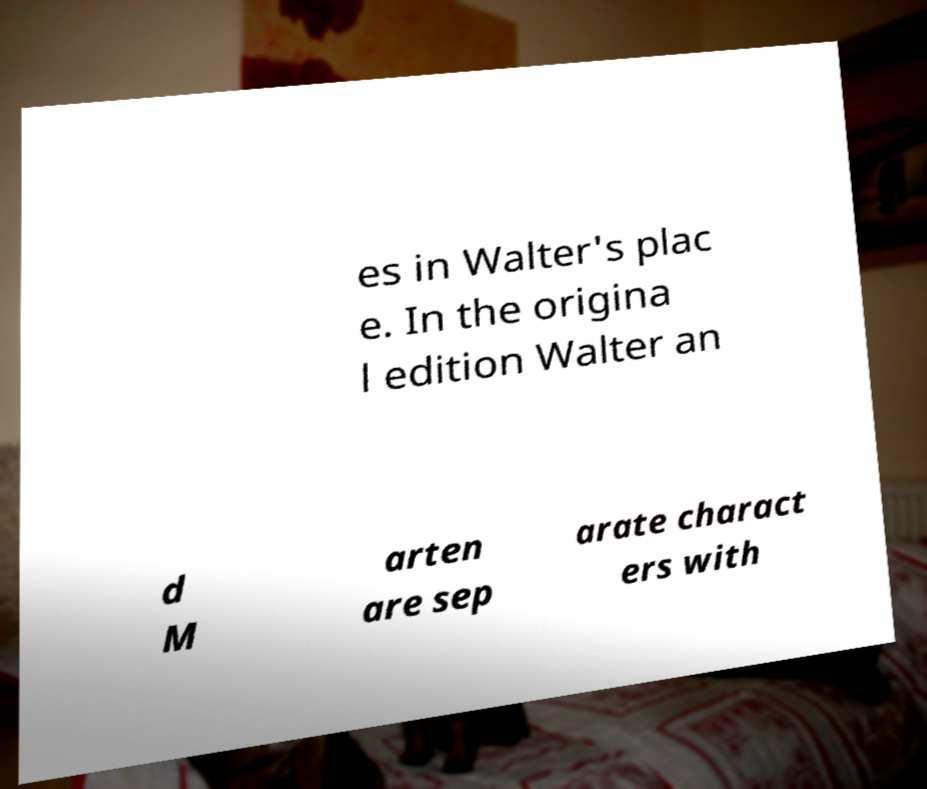What messages or text are displayed in this image? I need them in a readable, typed format. es in Walter's plac e. In the origina l edition Walter an d M arten are sep arate charact ers with 